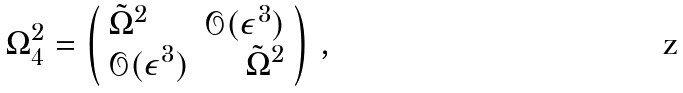Convert formula to latex. <formula><loc_0><loc_0><loc_500><loc_500>\Omega _ { 4 } ^ { 2 } = \left ( \begin{array} { l r } \tilde { \Omega } ^ { 2 } & \mathcal { O } ( \epsilon ^ { 3 } ) \\ \mathcal { O } ( \epsilon ^ { 3 } ) & \tilde { \Omega } ^ { 2 } \end{array} \right ) \, ,</formula> 